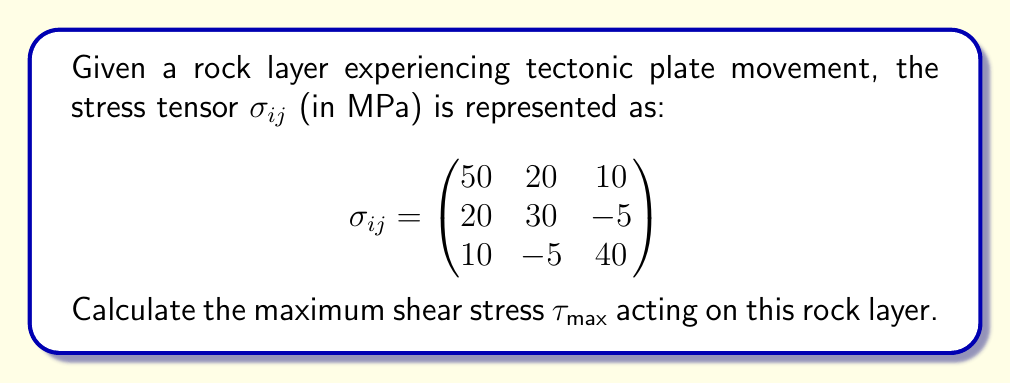Solve this math problem. To find the maximum shear stress, we need to follow these steps:

1) First, calculate the principal stresses by finding the eigenvalues of the stress tensor. However, for this problem, we'll use a shortcut method.

2) The maximum shear stress is given by the equation:

   $$\tau_{max} = \frac{\sigma_1 - \sigma_3}{2}$$

   where $\sigma_1$ is the maximum principal stress and $\sigma_3$ is the minimum principal stress.

3) For a 3x3 symmetric tensor, we can use the following formulas to find $\sigma_1$ and $\sigma_3$:

   $$\sigma_1 = \frac{I_1}{3} + \frac{2}{3}Q\cos(\theta)$$
   $$\sigma_3 = \frac{I_1}{3} + \frac{2}{3}Q\cos(\theta + \frac{4\pi}{3})$$

   where:
   $I_1 = \sigma_{11} + \sigma_{22} + \sigma_{33}$ (first invariant)
   $Q = \sqrt{\frac{1}{3}(3I_2 - I_1^2)}$
   $I_2 = \sigma_{11}\sigma_{22} + \sigma_{22}\sigma_{33} + \sigma_{33}\sigma_{11} - \sigma_{12}^2 - \sigma_{23}^2 - \sigma_{31}^2$ (second invariant)
   $\theta = \frac{1}{3}\arccos(\frac{1}{2Q^3}(2I_1^3 - 9I_1I_2 + 27I_3))$
   $I_3 = \det(\sigma_{ij})$ (third invariant)

4) Calculate the invariants:
   $I_1 = 50 + 30 + 40 = 120$ MPa
   $I_2 = 50(30) + 30(40) + 40(50) - 20^2 - (-5)^2 - 10^2 = 4275$ MPa²
   $I_3 = 50(30(40) - (-5)^2) - 20(20(40) - 10(-5)) + 10(20(-5) - 30(10)) = 54750$ MPa³

5) Calculate Q:
   $Q = \sqrt{\frac{1}{3}(3(4275) - 120^2)} = 24.49$ MPa

6) Calculate $\theta$:
   $\theta = \frac{1}{3}\arccos(\frac{1}{2(24.49)^3}(2(120)^3 - 9(120)(4275) + 27(54750))) = 0.1823$ rad

7) Now calculate $\sigma_1$ and $\sigma_3$:
   $\sigma_1 = \frac{120}{3} + \frac{2}{3}(24.49)\cos(0.1823) = 56.13$ MPa
   $\sigma_3 = \frac{120}{3} + \frac{2}{3}(24.49)\cos(0.1823 + \frac{4\pi}{3}) = 23.18$ MPa

8) Finally, calculate $\tau_{max}$:
   $$\tau_{max} = \frac{\sigma_1 - \sigma_3}{2} = \frac{56.13 - 23.18}{2} = 16.48$$ MPa
Answer: $\tau_{max} = 16.48$ MPa 